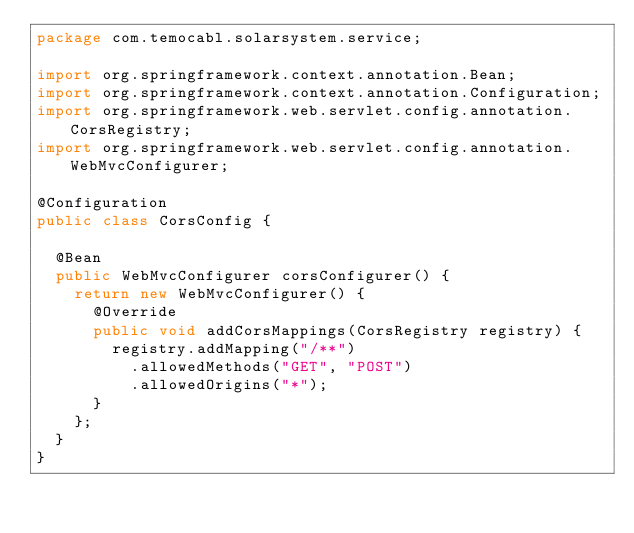Convert code to text. <code><loc_0><loc_0><loc_500><loc_500><_Java_>package com.temocabl.solarsystem.service;

import org.springframework.context.annotation.Bean;
import org.springframework.context.annotation.Configuration;
import org.springframework.web.servlet.config.annotation.CorsRegistry;
import org.springframework.web.servlet.config.annotation.WebMvcConfigurer;

@Configuration
public class CorsConfig {

  @Bean
  public WebMvcConfigurer corsConfigurer() {
    return new WebMvcConfigurer() {
      @Override
      public void addCorsMappings(CorsRegistry registry) {
        registry.addMapping("/**")
          .allowedMethods("GET", "POST")
          .allowedOrigins("*");
      }
    };
  }
}</code> 